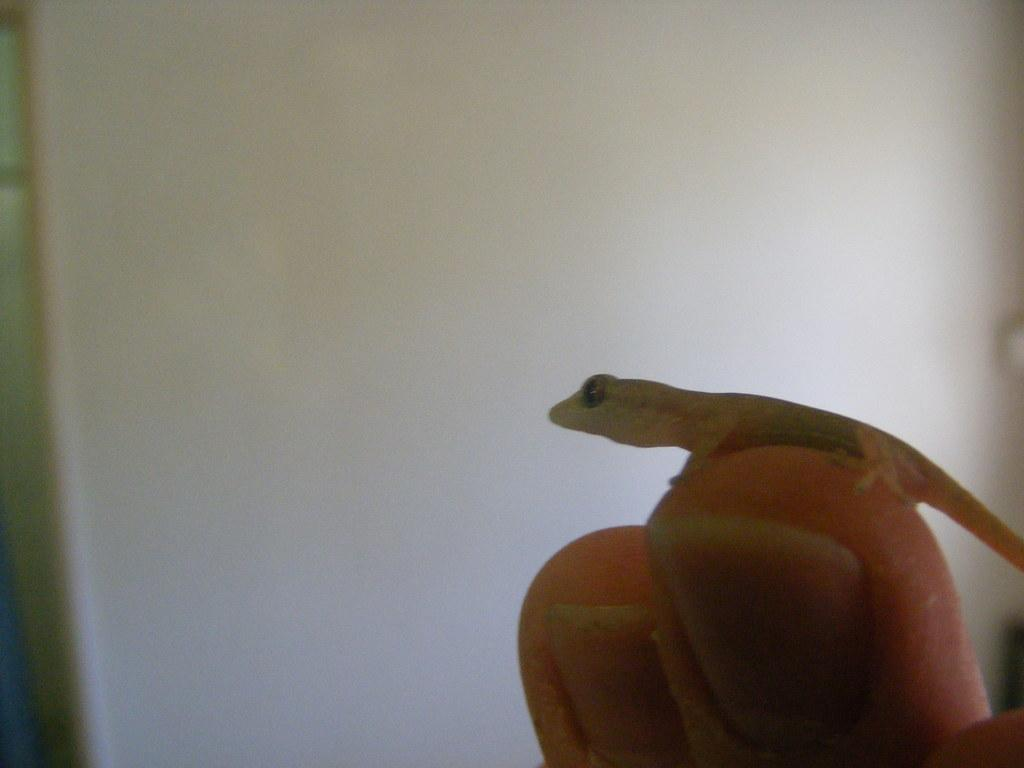What can be seen on the person's fingers in the image? There is a lizard on one of the fingers in the image. What is the background of the image? The background of the image is white, resembling a wall. What time is the event taking place in the image? There is no event or time mentioned in the image; it only shows a person's fingers with a lizard on one of them against a white background. 